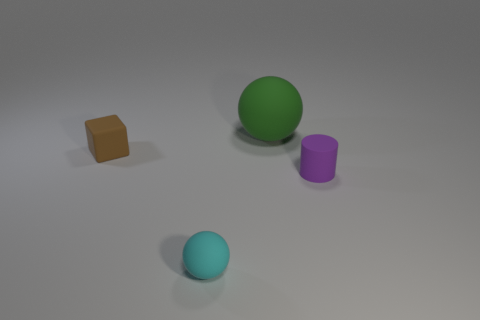Subtract all blocks. How many objects are left? 3 Subtract all tiny brown blocks. Subtract all rubber spheres. How many objects are left? 1 Add 4 small purple objects. How many small purple objects are left? 5 Add 2 tiny cubes. How many tiny cubes exist? 3 Add 4 cyan rubber objects. How many objects exist? 8 Subtract 1 purple cylinders. How many objects are left? 3 Subtract 1 blocks. How many blocks are left? 0 Subtract all green blocks. Subtract all blue balls. How many blocks are left? 1 Subtract all yellow blocks. How many cyan spheres are left? 1 